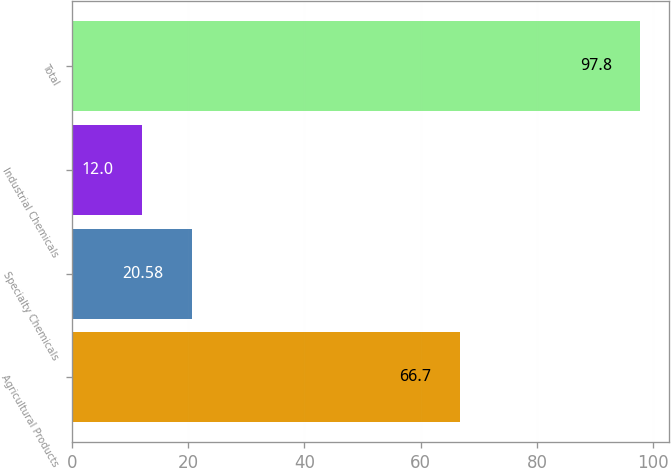Convert chart to OTSL. <chart><loc_0><loc_0><loc_500><loc_500><bar_chart><fcel>Agricultural Products<fcel>Specialty Chemicals<fcel>Industrial Chemicals<fcel>Total<nl><fcel>66.7<fcel>20.58<fcel>12<fcel>97.8<nl></chart> 